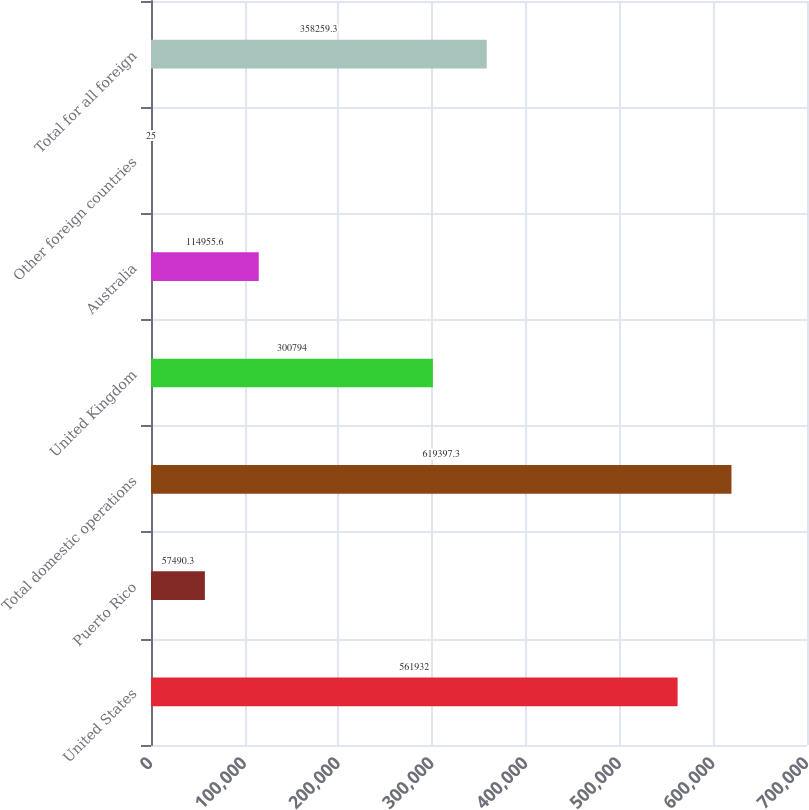<chart> <loc_0><loc_0><loc_500><loc_500><bar_chart><fcel>United States<fcel>Puerto Rico<fcel>Total domestic operations<fcel>United Kingdom<fcel>Australia<fcel>Other foreign countries<fcel>Total for all foreign<nl><fcel>561932<fcel>57490.3<fcel>619397<fcel>300794<fcel>114956<fcel>25<fcel>358259<nl></chart> 